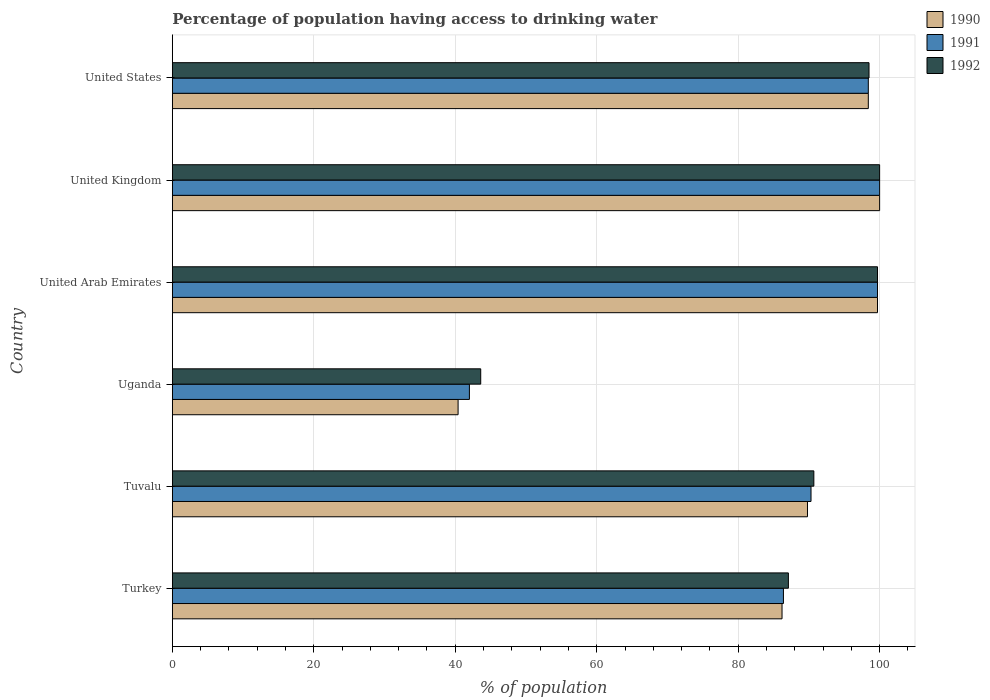Are the number of bars per tick equal to the number of legend labels?
Your answer should be very brief. Yes. Are the number of bars on each tick of the Y-axis equal?
Make the answer very short. Yes. In how many cases, is the number of bars for a given country not equal to the number of legend labels?
Make the answer very short. 0. What is the percentage of population having access to drinking water in 1992 in Tuvalu?
Provide a short and direct response. 90.7. Across all countries, what is the minimum percentage of population having access to drinking water in 1990?
Give a very brief answer. 40.4. In which country was the percentage of population having access to drinking water in 1990 maximum?
Your answer should be compact. United Kingdom. In which country was the percentage of population having access to drinking water in 1991 minimum?
Offer a very short reply. Uganda. What is the total percentage of population having access to drinking water in 1992 in the graph?
Give a very brief answer. 519.6. What is the difference between the percentage of population having access to drinking water in 1992 in Turkey and that in Uganda?
Your answer should be very brief. 43.5. What is the difference between the percentage of population having access to drinking water in 1992 in Uganda and the percentage of population having access to drinking water in 1991 in United Arab Emirates?
Provide a succinct answer. -56.1. What is the average percentage of population having access to drinking water in 1990 per country?
Your answer should be very brief. 85.75. In how many countries, is the percentage of population having access to drinking water in 1990 greater than 72 %?
Offer a very short reply. 5. What is the ratio of the percentage of population having access to drinking water in 1992 in Tuvalu to that in Uganda?
Make the answer very short. 2.08. Is the difference between the percentage of population having access to drinking water in 1990 in Uganda and United States greater than the difference between the percentage of population having access to drinking water in 1991 in Uganda and United States?
Offer a terse response. No. What is the difference between the highest and the second highest percentage of population having access to drinking water in 1992?
Offer a terse response. 0.3. What is the difference between the highest and the lowest percentage of population having access to drinking water in 1991?
Provide a short and direct response. 58. Is the sum of the percentage of population having access to drinking water in 1990 in Turkey and United Arab Emirates greater than the maximum percentage of population having access to drinking water in 1991 across all countries?
Ensure brevity in your answer.  Yes. What does the 1st bar from the bottom in Uganda represents?
Make the answer very short. 1990. How many bars are there?
Make the answer very short. 18. Are all the bars in the graph horizontal?
Offer a very short reply. Yes. How many countries are there in the graph?
Provide a succinct answer. 6. How many legend labels are there?
Your answer should be very brief. 3. How are the legend labels stacked?
Provide a short and direct response. Vertical. What is the title of the graph?
Offer a terse response. Percentage of population having access to drinking water. Does "1967" appear as one of the legend labels in the graph?
Your response must be concise. No. What is the label or title of the X-axis?
Ensure brevity in your answer.  % of population. What is the label or title of the Y-axis?
Provide a succinct answer. Country. What is the % of population in 1990 in Turkey?
Your answer should be compact. 86.2. What is the % of population in 1991 in Turkey?
Provide a short and direct response. 86.4. What is the % of population of 1992 in Turkey?
Keep it short and to the point. 87.1. What is the % of population of 1990 in Tuvalu?
Provide a short and direct response. 89.8. What is the % of population of 1991 in Tuvalu?
Give a very brief answer. 90.3. What is the % of population in 1992 in Tuvalu?
Provide a short and direct response. 90.7. What is the % of population in 1990 in Uganda?
Your response must be concise. 40.4. What is the % of population in 1992 in Uganda?
Offer a terse response. 43.6. What is the % of population in 1990 in United Arab Emirates?
Your response must be concise. 99.7. What is the % of population of 1991 in United Arab Emirates?
Offer a very short reply. 99.7. What is the % of population in 1992 in United Arab Emirates?
Offer a terse response. 99.7. What is the % of population in 1990 in United States?
Provide a short and direct response. 98.4. What is the % of population in 1991 in United States?
Your answer should be compact. 98.4. What is the % of population of 1992 in United States?
Make the answer very short. 98.5. Across all countries, what is the maximum % of population of 1990?
Your answer should be very brief. 100. Across all countries, what is the maximum % of population of 1991?
Give a very brief answer. 100. Across all countries, what is the maximum % of population in 1992?
Your answer should be compact. 100. Across all countries, what is the minimum % of population of 1990?
Your answer should be very brief. 40.4. Across all countries, what is the minimum % of population of 1991?
Ensure brevity in your answer.  42. Across all countries, what is the minimum % of population in 1992?
Keep it short and to the point. 43.6. What is the total % of population of 1990 in the graph?
Make the answer very short. 514.5. What is the total % of population of 1991 in the graph?
Your response must be concise. 516.8. What is the total % of population in 1992 in the graph?
Provide a succinct answer. 519.6. What is the difference between the % of population in 1991 in Turkey and that in Tuvalu?
Provide a short and direct response. -3.9. What is the difference between the % of population of 1992 in Turkey and that in Tuvalu?
Make the answer very short. -3.6. What is the difference between the % of population in 1990 in Turkey and that in Uganda?
Offer a very short reply. 45.8. What is the difference between the % of population in 1991 in Turkey and that in Uganda?
Offer a terse response. 44.4. What is the difference between the % of population in 1992 in Turkey and that in Uganda?
Provide a succinct answer. 43.5. What is the difference between the % of population in 1990 in Turkey and that in United Arab Emirates?
Your answer should be compact. -13.5. What is the difference between the % of population of 1992 in Turkey and that in United Arab Emirates?
Make the answer very short. -12.6. What is the difference between the % of population of 1992 in Turkey and that in United Kingdom?
Keep it short and to the point. -12.9. What is the difference between the % of population in 1992 in Turkey and that in United States?
Provide a succinct answer. -11.4. What is the difference between the % of population in 1990 in Tuvalu and that in Uganda?
Make the answer very short. 49.4. What is the difference between the % of population in 1991 in Tuvalu and that in Uganda?
Offer a terse response. 48.3. What is the difference between the % of population in 1992 in Tuvalu and that in Uganda?
Offer a terse response. 47.1. What is the difference between the % of population in 1992 in Tuvalu and that in United Arab Emirates?
Keep it short and to the point. -9. What is the difference between the % of population in 1990 in Tuvalu and that in United Kingdom?
Provide a succinct answer. -10.2. What is the difference between the % of population in 1991 in Tuvalu and that in United Kingdom?
Ensure brevity in your answer.  -9.7. What is the difference between the % of population in 1992 in Tuvalu and that in United Kingdom?
Your answer should be compact. -9.3. What is the difference between the % of population of 1992 in Tuvalu and that in United States?
Make the answer very short. -7.8. What is the difference between the % of population in 1990 in Uganda and that in United Arab Emirates?
Ensure brevity in your answer.  -59.3. What is the difference between the % of population of 1991 in Uganda and that in United Arab Emirates?
Your answer should be compact. -57.7. What is the difference between the % of population in 1992 in Uganda and that in United Arab Emirates?
Provide a short and direct response. -56.1. What is the difference between the % of population in 1990 in Uganda and that in United Kingdom?
Keep it short and to the point. -59.6. What is the difference between the % of population of 1991 in Uganda and that in United Kingdom?
Give a very brief answer. -58. What is the difference between the % of population of 1992 in Uganda and that in United Kingdom?
Your answer should be compact. -56.4. What is the difference between the % of population of 1990 in Uganda and that in United States?
Offer a very short reply. -58. What is the difference between the % of population of 1991 in Uganda and that in United States?
Your response must be concise. -56.4. What is the difference between the % of population of 1992 in Uganda and that in United States?
Make the answer very short. -54.9. What is the difference between the % of population in 1990 in United Arab Emirates and that in United Kingdom?
Give a very brief answer. -0.3. What is the difference between the % of population in 1992 in United Arab Emirates and that in United Kingdom?
Provide a succinct answer. -0.3. What is the difference between the % of population of 1990 in United Arab Emirates and that in United States?
Ensure brevity in your answer.  1.3. What is the difference between the % of population in 1991 in United Arab Emirates and that in United States?
Make the answer very short. 1.3. What is the difference between the % of population of 1990 in United Kingdom and that in United States?
Your response must be concise. 1.6. What is the difference between the % of population in 1991 in United Kingdom and that in United States?
Offer a terse response. 1.6. What is the difference between the % of population in 1992 in United Kingdom and that in United States?
Your answer should be very brief. 1.5. What is the difference between the % of population in 1990 in Turkey and the % of population in 1991 in Tuvalu?
Your answer should be very brief. -4.1. What is the difference between the % of population in 1990 in Turkey and the % of population in 1992 in Tuvalu?
Make the answer very short. -4.5. What is the difference between the % of population in 1990 in Turkey and the % of population in 1991 in Uganda?
Your answer should be compact. 44.2. What is the difference between the % of population in 1990 in Turkey and the % of population in 1992 in Uganda?
Provide a short and direct response. 42.6. What is the difference between the % of population in 1991 in Turkey and the % of population in 1992 in Uganda?
Offer a terse response. 42.8. What is the difference between the % of population in 1990 in Turkey and the % of population in 1991 in United Arab Emirates?
Give a very brief answer. -13.5. What is the difference between the % of population in 1990 in Turkey and the % of population in 1992 in United Arab Emirates?
Ensure brevity in your answer.  -13.5. What is the difference between the % of population of 1991 in Turkey and the % of population of 1992 in United Arab Emirates?
Keep it short and to the point. -13.3. What is the difference between the % of population of 1990 in Turkey and the % of population of 1992 in United Kingdom?
Your response must be concise. -13.8. What is the difference between the % of population of 1991 in Turkey and the % of population of 1992 in United Kingdom?
Your answer should be compact. -13.6. What is the difference between the % of population in 1990 in Turkey and the % of population in 1992 in United States?
Your answer should be compact. -12.3. What is the difference between the % of population in 1991 in Turkey and the % of population in 1992 in United States?
Provide a succinct answer. -12.1. What is the difference between the % of population of 1990 in Tuvalu and the % of population of 1991 in Uganda?
Offer a terse response. 47.8. What is the difference between the % of population in 1990 in Tuvalu and the % of population in 1992 in Uganda?
Provide a short and direct response. 46.2. What is the difference between the % of population of 1991 in Tuvalu and the % of population of 1992 in Uganda?
Keep it short and to the point. 46.7. What is the difference between the % of population of 1990 in Tuvalu and the % of population of 1991 in United Arab Emirates?
Offer a terse response. -9.9. What is the difference between the % of population in 1991 in Tuvalu and the % of population in 1992 in United Arab Emirates?
Provide a short and direct response. -9.4. What is the difference between the % of population of 1990 in Tuvalu and the % of population of 1992 in United Kingdom?
Your response must be concise. -10.2. What is the difference between the % of population of 1990 in Uganda and the % of population of 1991 in United Arab Emirates?
Ensure brevity in your answer.  -59.3. What is the difference between the % of population in 1990 in Uganda and the % of population in 1992 in United Arab Emirates?
Your answer should be compact. -59.3. What is the difference between the % of population of 1991 in Uganda and the % of population of 1992 in United Arab Emirates?
Offer a terse response. -57.7. What is the difference between the % of population of 1990 in Uganda and the % of population of 1991 in United Kingdom?
Provide a short and direct response. -59.6. What is the difference between the % of population in 1990 in Uganda and the % of population in 1992 in United Kingdom?
Offer a very short reply. -59.6. What is the difference between the % of population of 1991 in Uganda and the % of population of 1992 in United Kingdom?
Your answer should be very brief. -58. What is the difference between the % of population of 1990 in Uganda and the % of population of 1991 in United States?
Offer a terse response. -58. What is the difference between the % of population in 1990 in Uganda and the % of population in 1992 in United States?
Your response must be concise. -58.1. What is the difference between the % of population in 1991 in Uganda and the % of population in 1992 in United States?
Your answer should be very brief. -56.5. What is the difference between the % of population of 1990 in United Arab Emirates and the % of population of 1991 in United Kingdom?
Offer a very short reply. -0.3. What is the difference between the % of population of 1990 in United Arab Emirates and the % of population of 1991 in United States?
Make the answer very short. 1.3. What is the difference between the % of population in 1990 in United Arab Emirates and the % of population in 1992 in United States?
Your answer should be very brief. 1.2. What is the difference between the % of population in 1990 in United Kingdom and the % of population in 1992 in United States?
Keep it short and to the point. 1.5. What is the difference between the % of population of 1991 in United Kingdom and the % of population of 1992 in United States?
Offer a very short reply. 1.5. What is the average % of population of 1990 per country?
Give a very brief answer. 85.75. What is the average % of population in 1991 per country?
Make the answer very short. 86.13. What is the average % of population of 1992 per country?
Provide a short and direct response. 86.6. What is the difference between the % of population in 1990 and % of population in 1992 in Turkey?
Your answer should be very brief. -0.9. What is the difference between the % of population of 1991 and % of population of 1992 in Turkey?
Provide a succinct answer. -0.7. What is the difference between the % of population in 1990 and % of population in 1992 in Tuvalu?
Keep it short and to the point. -0.9. What is the difference between the % of population of 1990 and % of population of 1991 in Uganda?
Offer a terse response. -1.6. What is the difference between the % of population in 1991 and % of population in 1992 in Uganda?
Keep it short and to the point. -1.6. What is the difference between the % of population in 1990 and % of population in 1992 in United Arab Emirates?
Make the answer very short. 0. What is the difference between the % of population of 1991 and % of population of 1992 in United Arab Emirates?
Your answer should be very brief. 0. What is the difference between the % of population of 1990 and % of population of 1991 in United Kingdom?
Your response must be concise. 0. What is the difference between the % of population of 1990 and % of population of 1992 in United Kingdom?
Make the answer very short. 0. What is the difference between the % of population in 1991 and % of population in 1992 in United Kingdom?
Your answer should be very brief. 0. What is the difference between the % of population in 1991 and % of population in 1992 in United States?
Offer a very short reply. -0.1. What is the ratio of the % of population of 1990 in Turkey to that in Tuvalu?
Ensure brevity in your answer.  0.96. What is the ratio of the % of population of 1991 in Turkey to that in Tuvalu?
Your answer should be compact. 0.96. What is the ratio of the % of population in 1992 in Turkey to that in Tuvalu?
Keep it short and to the point. 0.96. What is the ratio of the % of population in 1990 in Turkey to that in Uganda?
Offer a terse response. 2.13. What is the ratio of the % of population of 1991 in Turkey to that in Uganda?
Make the answer very short. 2.06. What is the ratio of the % of population of 1992 in Turkey to that in Uganda?
Your answer should be compact. 2. What is the ratio of the % of population in 1990 in Turkey to that in United Arab Emirates?
Keep it short and to the point. 0.86. What is the ratio of the % of population in 1991 in Turkey to that in United Arab Emirates?
Your answer should be compact. 0.87. What is the ratio of the % of population of 1992 in Turkey to that in United Arab Emirates?
Ensure brevity in your answer.  0.87. What is the ratio of the % of population of 1990 in Turkey to that in United Kingdom?
Give a very brief answer. 0.86. What is the ratio of the % of population of 1991 in Turkey to that in United Kingdom?
Provide a short and direct response. 0.86. What is the ratio of the % of population of 1992 in Turkey to that in United Kingdom?
Your answer should be very brief. 0.87. What is the ratio of the % of population in 1990 in Turkey to that in United States?
Your answer should be compact. 0.88. What is the ratio of the % of population in 1991 in Turkey to that in United States?
Offer a terse response. 0.88. What is the ratio of the % of population in 1992 in Turkey to that in United States?
Offer a terse response. 0.88. What is the ratio of the % of population of 1990 in Tuvalu to that in Uganda?
Offer a very short reply. 2.22. What is the ratio of the % of population of 1991 in Tuvalu to that in Uganda?
Give a very brief answer. 2.15. What is the ratio of the % of population in 1992 in Tuvalu to that in Uganda?
Provide a succinct answer. 2.08. What is the ratio of the % of population of 1990 in Tuvalu to that in United Arab Emirates?
Ensure brevity in your answer.  0.9. What is the ratio of the % of population in 1991 in Tuvalu to that in United Arab Emirates?
Your response must be concise. 0.91. What is the ratio of the % of population in 1992 in Tuvalu to that in United Arab Emirates?
Provide a short and direct response. 0.91. What is the ratio of the % of population of 1990 in Tuvalu to that in United Kingdom?
Your answer should be very brief. 0.9. What is the ratio of the % of population in 1991 in Tuvalu to that in United Kingdom?
Offer a very short reply. 0.9. What is the ratio of the % of population in 1992 in Tuvalu to that in United Kingdom?
Ensure brevity in your answer.  0.91. What is the ratio of the % of population in 1990 in Tuvalu to that in United States?
Keep it short and to the point. 0.91. What is the ratio of the % of population in 1991 in Tuvalu to that in United States?
Ensure brevity in your answer.  0.92. What is the ratio of the % of population of 1992 in Tuvalu to that in United States?
Give a very brief answer. 0.92. What is the ratio of the % of population of 1990 in Uganda to that in United Arab Emirates?
Offer a very short reply. 0.41. What is the ratio of the % of population of 1991 in Uganda to that in United Arab Emirates?
Offer a very short reply. 0.42. What is the ratio of the % of population of 1992 in Uganda to that in United Arab Emirates?
Your answer should be very brief. 0.44. What is the ratio of the % of population of 1990 in Uganda to that in United Kingdom?
Make the answer very short. 0.4. What is the ratio of the % of population of 1991 in Uganda to that in United Kingdom?
Give a very brief answer. 0.42. What is the ratio of the % of population in 1992 in Uganda to that in United Kingdom?
Give a very brief answer. 0.44. What is the ratio of the % of population of 1990 in Uganda to that in United States?
Give a very brief answer. 0.41. What is the ratio of the % of population in 1991 in Uganda to that in United States?
Keep it short and to the point. 0.43. What is the ratio of the % of population in 1992 in Uganda to that in United States?
Offer a terse response. 0.44. What is the ratio of the % of population in 1990 in United Arab Emirates to that in United Kingdom?
Ensure brevity in your answer.  1. What is the ratio of the % of population of 1991 in United Arab Emirates to that in United Kingdom?
Make the answer very short. 1. What is the ratio of the % of population of 1990 in United Arab Emirates to that in United States?
Your answer should be compact. 1.01. What is the ratio of the % of population of 1991 in United Arab Emirates to that in United States?
Your answer should be compact. 1.01. What is the ratio of the % of population in 1992 in United Arab Emirates to that in United States?
Ensure brevity in your answer.  1.01. What is the ratio of the % of population in 1990 in United Kingdom to that in United States?
Your answer should be compact. 1.02. What is the ratio of the % of population in 1991 in United Kingdom to that in United States?
Your response must be concise. 1.02. What is the ratio of the % of population in 1992 in United Kingdom to that in United States?
Offer a very short reply. 1.02. What is the difference between the highest and the second highest % of population in 1992?
Your response must be concise. 0.3. What is the difference between the highest and the lowest % of population of 1990?
Ensure brevity in your answer.  59.6. What is the difference between the highest and the lowest % of population of 1992?
Offer a terse response. 56.4. 